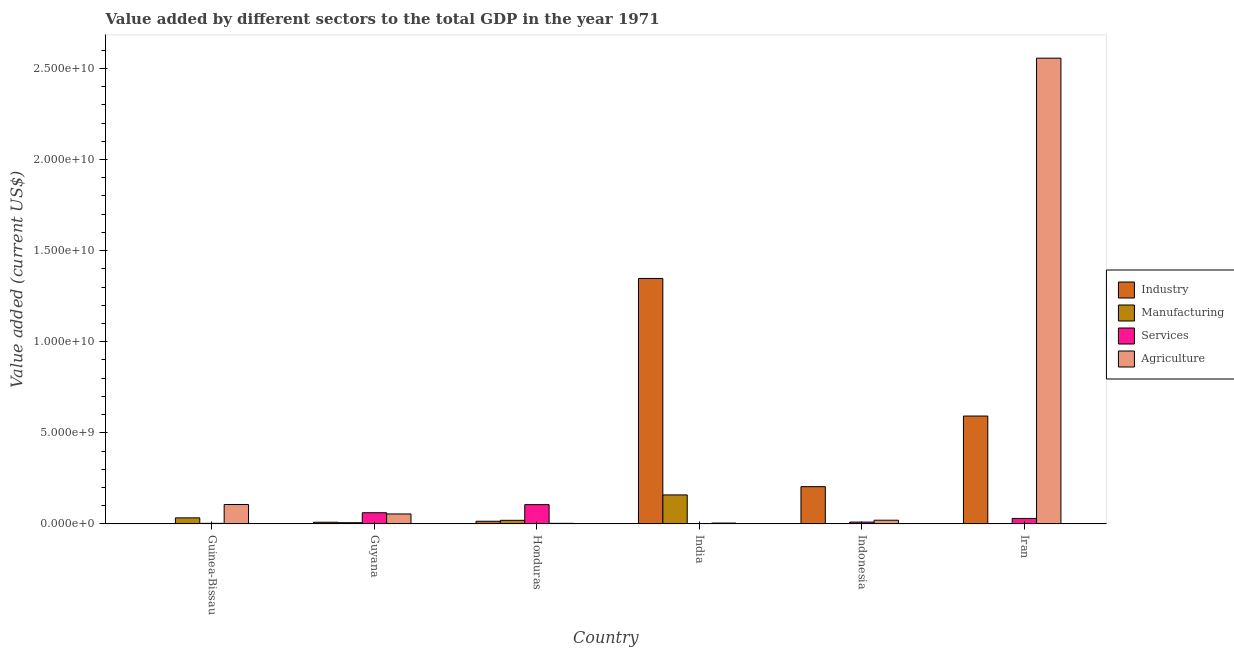How many groups of bars are there?
Provide a short and direct response. 6. What is the label of the 1st group of bars from the left?
Keep it short and to the point. Guinea-Bissau. In how many cases, is the number of bars for a given country not equal to the number of legend labels?
Offer a terse response. 0. What is the value added by industrial sector in Guinea-Bissau?
Provide a succinct answer. 1.73e+07. Across all countries, what is the maximum value added by industrial sector?
Your answer should be compact. 1.35e+1. Across all countries, what is the minimum value added by industrial sector?
Offer a terse response. 1.73e+07. In which country was the value added by agricultural sector maximum?
Your answer should be compact. Iran. What is the total value added by manufacturing sector in the graph?
Give a very brief answer. 2.22e+09. What is the difference between the value added by manufacturing sector in India and that in Indonesia?
Keep it short and to the point. 1.59e+09. What is the difference between the value added by services sector in Guyana and the value added by agricultural sector in India?
Offer a very short reply. 5.66e+08. What is the average value added by agricultural sector per country?
Make the answer very short. 4.58e+09. What is the difference between the value added by industrial sector and value added by manufacturing sector in Honduras?
Your answer should be very brief. -5.12e+07. In how many countries, is the value added by manufacturing sector greater than 6000000000 US$?
Ensure brevity in your answer.  0. What is the ratio of the value added by industrial sector in India to that in Iran?
Your response must be concise. 2.27. Is the value added by services sector in Guinea-Bissau less than that in Honduras?
Keep it short and to the point. Yes. What is the difference between the highest and the second highest value added by services sector?
Make the answer very short. 4.45e+08. What is the difference between the highest and the lowest value added by agricultural sector?
Offer a very short reply. 2.55e+1. In how many countries, is the value added by manufacturing sector greater than the average value added by manufacturing sector taken over all countries?
Ensure brevity in your answer.  1. Is the sum of the value added by agricultural sector in Guyana and Indonesia greater than the maximum value added by industrial sector across all countries?
Ensure brevity in your answer.  No. What does the 2nd bar from the left in India represents?
Make the answer very short. Manufacturing. What does the 2nd bar from the right in Indonesia represents?
Your response must be concise. Services. How many bars are there?
Keep it short and to the point. 24. What is the difference between two consecutive major ticks on the Y-axis?
Provide a short and direct response. 5.00e+09. Are the values on the major ticks of Y-axis written in scientific E-notation?
Keep it short and to the point. Yes. Does the graph contain grids?
Ensure brevity in your answer.  No. Where does the legend appear in the graph?
Offer a very short reply. Center right. What is the title of the graph?
Provide a short and direct response. Value added by different sectors to the total GDP in the year 1971. Does "Social Insurance" appear as one of the legend labels in the graph?
Give a very brief answer. No. What is the label or title of the Y-axis?
Ensure brevity in your answer.  Value added (current US$). What is the Value added (current US$) in Industry in Guinea-Bissau?
Provide a succinct answer. 1.73e+07. What is the Value added (current US$) in Manufacturing in Guinea-Bissau?
Give a very brief answer. 3.35e+08. What is the Value added (current US$) of Services in Guinea-Bissau?
Your answer should be compact. 3.42e+07. What is the Value added (current US$) in Agriculture in Guinea-Bissau?
Your answer should be compact. 1.07e+09. What is the Value added (current US$) of Industry in Guyana?
Your answer should be compact. 9.53e+07. What is the Value added (current US$) of Manufacturing in Guyana?
Keep it short and to the point. 7.08e+07. What is the Value added (current US$) of Services in Guyana?
Provide a succinct answer. 6.17e+08. What is the Value added (current US$) of Agriculture in Guyana?
Offer a terse response. 5.50e+08. What is the Value added (current US$) of Industry in Honduras?
Offer a very short reply. 1.50e+08. What is the Value added (current US$) of Manufacturing in Honduras?
Ensure brevity in your answer.  2.01e+08. What is the Value added (current US$) of Services in Honduras?
Offer a terse response. 1.06e+09. What is the Value added (current US$) of Agriculture in Honduras?
Your answer should be very brief. 3.52e+07. What is the Value added (current US$) in Industry in India?
Your answer should be very brief. 1.35e+1. What is the Value added (current US$) of Manufacturing in India?
Your response must be concise. 1.59e+09. What is the Value added (current US$) of Services in India?
Make the answer very short. 2.60e+07. What is the Value added (current US$) in Agriculture in India?
Your answer should be compact. 5.08e+07. What is the Value added (current US$) of Industry in Indonesia?
Your answer should be compact. 2.05e+09. What is the Value added (current US$) in Manufacturing in Indonesia?
Your response must be concise. 3.36e+06. What is the Value added (current US$) of Services in Indonesia?
Ensure brevity in your answer.  1.03e+08. What is the Value added (current US$) in Agriculture in Indonesia?
Offer a terse response. 2.06e+08. What is the Value added (current US$) of Industry in Iran?
Your answer should be compact. 5.92e+09. What is the Value added (current US$) of Manufacturing in Iran?
Provide a succinct answer. 1.46e+07. What is the Value added (current US$) of Services in Iran?
Ensure brevity in your answer.  3.04e+08. What is the Value added (current US$) in Agriculture in Iran?
Your answer should be very brief. 2.56e+1. Across all countries, what is the maximum Value added (current US$) of Industry?
Make the answer very short. 1.35e+1. Across all countries, what is the maximum Value added (current US$) in Manufacturing?
Your answer should be compact. 1.59e+09. Across all countries, what is the maximum Value added (current US$) of Services?
Provide a short and direct response. 1.06e+09. Across all countries, what is the maximum Value added (current US$) of Agriculture?
Your response must be concise. 2.56e+1. Across all countries, what is the minimum Value added (current US$) of Industry?
Offer a very short reply. 1.73e+07. Across all countries, what is the minimum Value added (current US$) of Manufacturing?
Provide a succinct answer. 3.36e+06. Across all countries, what is the minimum Value added (current US$) in Services?
Ensure brevity in your answer.  2.60e+07. Across all countries, what is the minimum Value added (current US$) in Agriculture?
Offer a terse response. 3.52e+07. What is the total Value added (current US$) in Industry in the graph?
Keep it short and to the point. 2.17e+1. What is the total Value added (current US$) of Manufacturing in the graph?
Offer a very short reply. 2.22e+09. What is the total Value added (current US$) of Services in the graph?
Your response must be concise. 2.15e+09. What is the total Value added (current US$) in Agriculture in the graph?
Provide a short and direct response. 2.75e+1. What is the difference between the Value added (current US$) of Industry in Guinea-Bissau and that in Guyana?
Your answer should be very brief. -7.80e+07. What is the difference between the Value added (current US$) of Manufacturing in Guinea-Bissau and that in Guyana?
Your answer should be very brief. 2.64e+08. What is the difference between the Value added (current US$) in Services in Guinea-Bissau and that in Guyana?
Offer a terse response. -5.83e+08. What is the difference between the Value added (current US$) of Agriculture in Guinea-Bissau and that in Guyana?
Offer a very short reply. 5.18e+08. What is the difference between the Value added (current US$) of Industry in Guinea-Bissau and that in Honduras?
Provide a succinct answer. -1.32e+08. What is the difference between the Value added (current US$) of Manufacturing in Guinea-Bissau and that in Honduras?
Provide a succinct answer. 1.35e+08. What is the difference between the Value added (current US$) of Services in Guinea-Bissau and that in Honduras?
Offer a terse response. -1.03e+09. What is the difference between the Value added (current US$) in Agriculture in Guinea-Bissau and that in Honduras?
Make the answer very short. 1.03e+09. What is the difference between the Value added (current US$) in Industry in Guinea-Bissau and that in India?
Your response must be concise. -1.35e+1. What is the difference between the Value added (current US$) in Manufacturing in Guinea-Bissau and that in India?
Give a very brief answer. -1.26e+09. What is the difference between the Value added (current US$) of Services in Guinea-Bissau and that in India?
Offer a very short reply. 8.27e+06. What is the difference between the Value added (current US$) in Agriculture in Guinea-Bissau and that in India?
Provide a short and direct response. 1.02e+09. What is the difference between the Value added (current US$) in Industry in Guinea-Bissau and that in Indonesia?
Offer a very short reply. -2.03e+09. What is the difference between the Value added (current US$) in Manufacturing in Guinea-Bissau and that in Indonesia?
Provide a short and direct response. 3.32e+08. What is the difference between the Value added (current US$) in Services in Guinea-Bissau and that in Indonesia?
Provide a succinct answer. -6.88e+07. What is the difference between the Value added (current US$) in Agriculture in Guinea-Bissau and that in Indonesia?
Ensure brevity in your answer.  8.61e+08. What is the difference between the Value added (current US$) of Industry in Guinea-Bissau and that in Iran?
Give a very brief answer. -5.91e+09. What is the difference between the Value added (current US$) in Manufacturing in Guinea-Bissau and that in Iran?
Give a very brief answer. 3.21e+08. What is the difference between the Value added (current US$) of Services in Guinea-Bissau and that in Iran?
Offer a terse response. -2.69e+08. What is the difference between the Value added (current US$) of Agriculture in Guinea-Bissau and that in Iran?
Keep it short and to the point. -2.45e+1. What is the difference between the Value added (current US$) of Industry in Guyana and that in Honduras?
Give a very brief answer. -5.42e+07. What is the difference between the Value added (current US$) in Manufacturing in Guyana and that in Honduras?
Provide a succinct answer. -1.30e+08. What is the difference between the Value added (current US$) in Services in Guyana and that in Honduras?
Your answer should be very brief. -4.45e+08. What is the difference between the Value added (current US$) in Agriculture in Guyana and that in Honduras?
Keep it short and to the point. 5.15e+08. What is the difference between the Value added (current US$) in Industry in Guyana and that in India?
Your response must be concise. -1.34e+1. What is the difference between the Value added (current US$) in Manufacturing in Guyana and that in India?
Ensure brevity in your answer.  -1.52e+09. What is the difference between the Value added (current US$) of Services in Guyana and that in India?
Your answer should be very brief. 5.91e+08. What is the difference between the Value added (current US$) of Agriculture in Guyana and that in India?
Your response must be concise. 4.99e+08. What is the difference between the Value added (current US$) of Industry in Guyana and that in Indonesia?
Your answer should be very brief. -1.95e+09. What is the difference between the Value added (current US$) in Manufacturing in Guyana and that in Indonesia?
Provide a succinct answer. 6.75e+07. What is the difference between the Value added (current US$) of Services in Guyana and that in Indonesia?
Your answer should be very brief. 5.14e+08. What is the difference between the Value added (current US$) in Agriculture in Guyana and that in Indonesia?
Offer a terse response. 3.43e+08. What is the difference between the Value added (current US$) of Industry in Guyana and that in Iran?
Make the answer very short. -5.83e+09. What is the difference between the Value added (current US$) in Manufacturing in Guyana and that in Iran?
Ensure brevity in your answer.  5.62e+07. What is the difference between the Value added (current US$) in Services in Guyana and that in Iran?
Provide a succinct answer. 3.13e+08. What is the difference between the Value added (current US$) of Agriculture in Guyana and that in Iran?
Make the answer very short. -2.50e+1. What is the difference between the Value added (current US$) in Industry in Honduras and that in India?
Provide a short and direct response. -1.33e+1. What is the difference between the Value added (current US$) of Manufacturing in Honduras and that in India?
Give a very brief answer. -1.39e+09. What is the difference between the Value added (current US$) of Services in Honduras and that in India?
Offer a very short reply. 1.04e+09. What is the difference between the Value added (current US$) of Agriculture in Honduras and that in India?
Keep it short and to the point. -1.56e+07. What is the difference between the Value added (current US$) in Industry in Honduras and that in Indonesia?
Your answer should be compact. -1.90e+09. What is the difference between the Value added (current US$) in Manufacturing in Honduras and that in Indonesia?
Your answer should be very brief. 1.97e+08. What is the difference between the Value added (current US$) of Services in Honduras and that in Indonesia?
Your response must be concise. 9.59e+08. What is the difference between the Value added (current US$) of Agriculture in Honduras and that in Indonesia?
Ensure brevity in your answer.  -1.71e+08. What is the difference between the Value added (current US$) of Industry in Honduras and that in Iran?
Give a very brief answer. -5.77e+09. What is the difference between the Value added (current US$) of Manufacturing in Honduras and that in Iran?
Your answer should be compact. 1.86e+08. What is the difference between the Value added (current US$) in Services in Honduras and that in Iran?
Keep it short and to the point. 7.58e+08. What is the difference between the Value added (current US$) in Agriculture in Honduras and that in Iran?
Give a very brief answer. -2.55e+1. What is the difference between the Value added (current US$) in Industry in India and that in Indonesia?
Offer a terse response. 1.14e+1. What is the difference between the Value added (current US$) in Manufacturing in India and that in Indonesia?
Your response must be concise. 1.59e+09. What is the difference between the Value added (current US$) of Services in India and that in Indonesia?
Provide a short and direct response. -7.71e+07. What is the difference between the Value added (current US$) of Agriculture in India and that in Indonesia?
Your response must be concise. -1.56e+08. What is the difference between the Value added (current US$) of Industry in India and that in Iran?
Keep it short and to the point. 7.55e+09. What is the difference between the Value added (current US$) of Manufacturing in India and that in Iran?
Provide a short and direct response. 1.58e+09. What is the difference between the Value added (current US$) in Services in India and that in Iran?
Ensure brevity in your answer.  -2.78e+08. What is the difference between the Value added (current US$) of Agriculture in India and that in Iran?
Ensure brevity in your answer.  -2.55e+1. What is the difference between the Value added (current US$) in Industry in Indonesia and that in Iran?
Provide a short and direct response. -3.88e+09. What is the difference between the Value added (current US$) in Manufacturing in Indonesia and that in Iran?
Offer a terse response. -1.12e+07. What is the difference between the Value added (current US$) in Services in Indonesia and that in Iran?
Your answer should be compact. -2.00e+08. What is the difference between the Value added (current US$) in Agriculture in Indonesia and that in Iran?
Provide a short and direct response. -2.54e+1. What is the difference between the Value added (current US$) of Industry in Guinea-Bissau and the Value added (current US$) of Manufacturing in Guyana?
Offer a terse response. -5.35e+07. What is the difference between the Value added (current US$) in Industry in Guinea-Bissau and the Value added (current US$) in Services in Guyana?
Offer a terse response. -6.00e+08. What is the difference between the Value added (current US$) of Industry in Guinea-Bissau and the Value added (current US$) of Agriculture in Guyana?
Ensure brevity in your answer.  -5.32e+08. What is the difference between the Value added (current US$) of Manufacturing in Guinea-Bissau and the Value added (current US$) of Services in Guyana?
Make the answer very short. -2.82e+08. What is the difference between the Value added (current US$) in Manufacturing in Guinea-Bissau and the Value added (current US$) in Agriculture in Guyana?
Offer a very short reply. -2.15e+08. What is the difference between the Value added (current US$) in Services in Guinea-Bissau and the Value added (current US$) in Agriculture in Guyana?
Offer a terse response. -5.16e+08. What is the difference between the Value added (current US$) of Industry in Guinea-Bissau and the Value added (current US$) of Manufacturing in Honduras?
Offer a very short reply. -1.83e+08. What is the difference between the Value added (current US$) of Industry in Guinea-Bissau and the Value added (current US$) of Services in Honduras?
Offer a very short reply. -1.04e+09. What is the difference between the Value added (current US$) in Industry in Guinea-Bissau and the Value added (current US$) in Agriculture in Honduras?
Your answer should be very brief. -1.79e+07. What is the difference between the Value added (current US$) of Manufacturing in Guinea-Bissau and the Value added (current US$) of Services in Honduras?
Your response must be concise. -7.26e+08. What is the difference between the Value added (current US$) in Manufacturing in Guinea-Bissau and the Value added (current US$) in Agriculture in Honduras?
Offer a terse response. 3.00e+08. What is the difference between the Value added (current US$) of Services in Guinea-Bissau and the Value added (current US$) of Agriculture in Honduras?
Keep it short and to the point. -9.85e+05. What is the difference between the Value added (current US$) of Industry in Guinea-Bissau and the Value added (current US$) of Manufacturing in India?
Provide a succinct answer. -1.58e+09. What is the difference between the Value added (current US$) of Industry in Guinea-Bissau and the Value added (current US$) of Services in India?
Your response must be concise. -8.63e+06. What is the difference between the Value added (current US$) in Industry in Guinea-Bissau and the Value added (current US$) in Agriculture in India?
Your answer should be very brief. -3.35e+07. What is the difference between the Value added (current US$) in Manufacturing in Guinea-Bissau and the Value added (current US$) in Services in India?
Your answer should be compact. 3.09e+08. What is the difference between the Value added (current US$) of Manufacturing in Guinea-Bissau and the Value added (current US$) of Agriculture in India?
Make the answer very short. 2.84e+08. What is the difference between the Value added (current US$) in Services in Guinea-Bissau and the Value added (current US$) in Agriculture in India?
Offer a very short reply. -1.66e+07. What is the difference between the Value added (current US$) in Industry in Guinea-Bissau and the Value added (current US$) in Manufacturing in Indonesia?
Give a very brief answer. 1.40e+07. What is the difference between the Value added (current US$) of Industry in Guinea-Bissau and the Value added (current US$) of Services in Indonesia?
Offer a very short reply. -8.57e+07. What is the difference between the Value added (current US$) of Industry in Guinea-Bissau and the Value added (current US$) of Agriculture in Indonesia?
Give a very brief answer. -1.89e+08. What is the difference between the Value added (current US$) in Manufacturing in Guinea-Bissau and the Value added (current US$) in Services in Indonesia?
Offer a very short reply. 2.32e+08. What is the difference between the Value added (current US$) of Manufacturing in Guinea-Bissau and the Value added (current US$) of Agriculture in Indonesia?
Your answer should be compact. 1.29e+08. What is the difference between the Value added (current US$) of Services in Guinea-Bissau and the Value added (current US$) of Agriculture in Indonesia?
Ensure brevity in your answer.  -1.72e+08. What is the difference between the Value added (current US$) of Industry in Guinea-Bissau and the Value added (current US$) of Manufacturing in Iran?
Your answer should be compact. 2.74e+06. What is the difference between the Value added (current US$) in Industry in Guinea-Bissau and the Value added (current US$) in Services in Iran?
Your response must be concise. -2.86e+08. What is the difference between the Value added (current US$) of Industry in Guinea-Bissau and the Value added (current US$) of Agriculture in Iran?
Give a very brief answer. -2.55e+1. What is the difference between the Value added (current US$) in Manufacturing in Guinea-Bissau and the Value added (current US$) in Services in Iran?
Your response must be concise. 3.17e+07. What is the difference between the Value added (current US$) in Manufacturing in Guinea-Bissau and the Value added (current US$) in Agriculture in Iran?
Provide a succinct answer. -2.52e+1. What is the difference between the Value added (current US$) of Services in Guinea-Bissau and the Value added (current US$) of Agriculture in Iran?
Provide a succinct answer. -2.55e+1. What is the difference between the Value added (current US$) of Industry in Guyana and the Value added (current US$) of Manufacturing in Honduras?
Make the answer very short. -1.05e+08. What is the difference between the Value added (current US$) of Industry in Guyana and the Value added (current US$) of Services in Honduras?
Provide a succinct answer. -9.66e+08. What is the difference between the Value added (current US$) in Industry in Guyana and the Value added (current US$) in Agriculture in Honduras?
Offer a very short reply. 6.01e+07. What is the difference between the Value added (current US$) of Manufacturing in Guyana and the Value added (current US$) of Services in Honduras?
Your answer should be very brief. -9.91e+08. What is the difference between the Value added (current US$) of Manufacturing in Guyana and the Value added (current US$) of Agriculture in Honduras?
Offer a terse response. 3.56e+07. What is the difference between the Value added (current US$) in Services in Guyana and the Value added (current US$) in Agriculture in Honduras?
Your response must be concise. 5.82e+08. What is the difference between the Value added (current US$) in Industry in Guyana and the Value added (current US$) in Manufacturing in India?
Offer a terse response. -1.50e+09. What is the difference between the Value added (current US$) of Industry in Guyana and the Value added (current US$) of Services in India?
Your answer should be very brief. 6.93e+07. What is the difference between the Value added (current US$) of Industry in Guyana and the Value added (current US$) of Agriculture in India?
Your answer should be very brief. 4.44e+07. What is the difference between the Value added (current US$) of Manufacturing in Guyana and the Value added (current US$) of Services in India?
Your response must be concise. 4.49e+07. What is the difference between the Value added (current US$) of Manufacturing in Guyana and the Value added (current US$) of Agriculture in India?
Keep it short and to the point. 2.00e+07. What is the difference between the Value added (current US$) of Services in Guyana and the Value added (current US$) of Agriculture in India?
Make the answer very short. 5.66e+08. What is the difference between the Value added (current US$) of Industry in Guyana and the Value added (current US$) of Manufacturing in Indonesia?
Provide a short and direct response. 9.19e+07. What is the difference between the Value added (current US$) in Industry in Guyana and the Value added (current US$) in Services in Indonesia?
Your answer should be very brief. -7.75e+06. What is the difference between the Value added (current US$) of Industry in Guyana and the Value added (current US$) of Agriculture in Indonesia?
Make the answer very short. -1.11e+08. What is the difference between the Value added (current US$) in Manufacturing in Guyana and the Value added (current US$) in Services in Indonesia?
Give a very brief answer. -3.22e+07. What is the difference between the Value added (current US$) in Manufacturing in Guyana and the Value added (current US$) in Agriculture in Indonesia?
Make the answer very short. -1.36e+08. What is the difference between the Value added (current US$) in Services in Guyana and the Value added (current US$) in Agriculture in Indonesia?
Offer a terse response. 4.10e+08. What is the difference between the Value added (current US$) in Industry in Guyana and the Value added (current US$) in Manufacturing in Iran?
Give a very brief answer. 8.07e+07. What is the difference between the Value added (current US$) in Industry in Guyana and the Value added (current US$) in Services in Iran?
Give a very brief answer. -2.08e+08. What is the difference between the Value added (current US$) of Industry in Guyana and the Value added (current US$) of Agriculture in Iran?
Your answer should be very brief. -2.55e+1. What is the difference between the Value added (current US$) in Manufacturing in Guyana and the Value added (current US$) in Services in Iran?
Offer a terse response. -2.33e+08. What is the difference between the Value added (current US$) in Manufacturing in Guyana and the Value added (current US$) in Agriculture in Iran?
Your response must be concise. -2.55e+1. What is the difference between the Value added (current US$) in Services in Guyana and the Value added (current US$) in Agriculture in Iran?
Your answer should be very brief. -2.49e+1. What is the difference between the Value added (current US$) of Industry in Honduras and the Value added (current US$) of Manufacturing in India?
Provide a succinct answer. -1.45e+09. What is the difference between the Value added (current US$) of Industry in Honduras and the Value added (current US$) of Services in India?
Keep it short and to the point. 1.24e+08. What is the difference between the Value added (current US$) in Industry in Honduras and the Value added (current US$) in Agriculture in India?
Provide a short and direct response. 9.86e+07. What is the difference between the Value added (current US$) in Manufacturing in Honduras and the Value added (current US$) in Services in India?
Your response must be concise. 1.75e+08. What is the difference between the Value added (current US$) in Manufacturing in Honduras and the Value added (current US$) in Agriculture in India?
Provide a succinct answer. 1.50e+08. What is the difference between the Value added (current US$) in Services in Honduras and the Value added (current US$) in Agriculture in India?
Offer a terse response. 1.01e+09. What is the difference between the Value added (current US$) in Industry in Honduras and the Value added (current US$) in Manufacturing in Indonesia?
Keep it short and to the point. 1.46e+08. What is the difference between the Value added (current US$) of Industry in Honduras and the Value added (current US$) of Services in Indonesia?
Give a very brief answer. 4.64e+07. What is the difference between the Value added (current US$) of Industry in Honduras and the Value added (current US$) of Agriculture in Indonesia?
Keep it short and to the point. -5.70e+07. What is the difference between the Value added (current US$) in Manufacturing in Honduras and the Value added (current US$) in Services in Indonesia?
Your response must be concise. 9.77e+07. What is the difference between the Value added (current US$) in Manufacturing in Honduras and the Value added (current US$) in Agriculture in Indonesia?
Provide a short and direct response. -5.80e+06. What is the difference between the Value added (current US$) in Services in Honduras and the Value added (current US$) in Agriculture in Indonesia?
Your answer should be very brief. 8.55e+08. What is the difference between the Value added (current US$) of Industry in Honduras and the Value added (current US$) of Manufacturing in Iran?
Ensure brevity in your answer.  1.35e+08. What is the difference between the Value added (current US$) of Industry in Honduras and the Value added (current US$) of Services in Iran?
Offer a very short reply. -1.54e+08. What is the difference between the Value added (current US$) of Industry in Honduras and the Value added (current US$) of Agriculture in Iran?
Provide a succinct answer. -2.54e+1. What is the difference between the Value added (current US$) in Manufacturing in Honduras and the Value added (current US$) in Services in Iran?
Provide a short and direct response. -1.03e+08. What is the difference between the Value added (current US$) in Manufacturing in Honduras and the Value added (current US$) in Agriculture in Iran?
Provide a short and direct response. -2.54e+1. What is the difference between the Value added (current US$) of Services in Honduras and the Value added (current US$) of Agriculture in Iran?
Provide a short and direct response. -2.45e+1. What is the difference between the Value added (current US$) in Industry in India and the Value added (current US$) in Manufacturing in Indonesia?
Your response must be concise. 1.35e+1. What is the difference between the Value added (current US$) in Industry in India and the Value added (current US$) in Services in Indonesia?
Offer a very short reply. 1.34e+1. What is the difference between the Value added (current US$) of Industry in India and the Value added (current US$) of Agriculture in Indonesia?
Provide a short and direct response. 1.33e+1. What is the difference between the Value added (current US$) in Manufacturing in India and the Value added (current US$) in Services in Indonesia?
Your answer should be very brief. 1.49e+09. What is the difference between the Value added (current US$) of Manufacturing in India and the Value added (current US$) of Agriculture in Indonesia?
Provide a short and direct response. 1.39e+09. What is the difference between the Value added (current US$) of Services in India and the Value added (current US$) of Agriculture in Indonesia?
Keep it short and to the point. -1.81e+08. What is the difference between the Value added (current US$) of Industry in India and the Value added (current US$) of Manufacturing in Iran?
Provide a short and direct response. 1.35e+1. What is the difference between the Value added (current US$) of Industry in India and the Value added (current US$) of Services in Iran?
Ensure brevity in your answer.  1.32e+1. What is the difference between the Value added (current US$) of Industry in India and the Value added (current US$) of Agriculture in Iran?
Ensure brevity in your answer.  -1.21e+1. What is the difference between the Value added (current US$) in Manufacturing in India and the Value added (current US$) in Services in Iran?
Provide a short and direct response. 1.29e+09. What is the difference between the Value added (current US$) of Manufacturing in India and the Value added (current US$) of Agriculture in Iran?
Provide a short and direct response. -2.40e+1. What is the difference between the Value added (current US$) in Services in India and the Value added (current US$) in Agriculture in Iran?
Offer a terse response. -2.55e+1. What is the difference between the Value added (current US$) in Industry in Indonesia and the Value added (current US$) in Manufacturing in Iran?
Your answer should be compact. 2.03e+09. What is the difference between the Value added (current US$) in Industry in Indonesia and the Value added (current US$) in Services in Iran?
Ensure brevity in your answer.  1.74e+09. What is the difference between the Value added (current US$) of Industry in Indonesia and the Value added (current US$) of Agriculture in Iran?
Your answer should be very brief. -2.35e+1. What is the difference between the Value added (current US$) in Manufacturing in Indonesia and the Value added (current US$) in Services in Iran?
Provide a short and direct response. -3.00e+08. What is the difference between the Value added (current US$) of Manufacturing in Indonesia and the Value added (current US$) of Agriculture in Iran?
Keep it short and to the point. -2.56e+1. What is the difference between the Value added (current US$) of Services in Indonesia and the Value added (current US$) of Agriculture in Iran?
Provide a succinct answer. -2.55e+1. What is the average Value added (current US$) of Industry per country?
Provide a succinct answer. 3.62e+09. What is the average Value added (current US$) in Manufacturing per country?
Your answer should be compact. 3.70e+08. What is the average Value added (current US$) in Services per country?
Keep it short and to the point. 3.58e+08. What is the average Value added (current US$) in Agriculture per country?
Your answer should be compact. 4.58e+09. What is the difference between the Value added (current US$) in Industry and Value added (current US$) in Manufacturing in Guinea-Bissau?
Provide a succinct answer. -3.18e+08. What is the difference between the Value added (current US$) in Industry and Value added (current US$) in Services in Guinea-Bissau?
Offer a terse response. -1.69e+07. What is the difference between the Value added (current US$) in Industry and Value added (current US$) in Agriculture in Guinea-Bissau?
Offer a very short reply. -1.05e+09. What is the difference between the Value added (current US$) of Manufacturing and Value added (current US$) of Services in Guinea-Bissau?
Your answer should be compact. 3.01e+08. What is the difference between the Value added (current US$) in Manufacturing and Value added (current US$) in Agriculture in Guinea-Bissau?
Keep it short and to the point. -7.32e+08. What is the difference between the Value added (current US$) in Services and Value added (current US$) in Agriculture in Guinea-Bissau?
Your response must be concise. -1.03e+09. What is the difference between the Value added (current US$) of Industry and Value added (current US$) of Manufacturing in Guyana?
Your answer should be compact. 2.45e+07. What is the difference between the Value added (current US$) of Industry and Value added (current US$) of Services in Guyana?
Your answer should be compact. -5.22e+08. What is the difference between the Value added (current US$) in Industry and Value added (current US$) in Agriculture in Guyana?
Your response must be concise. -4.54e+08. What is the difference between the Value added (current US$) in Manufacturing and Value added (current US$) in Services in Guyana?
Ensure brevity in your answer.  -5.46e+08. What is the difference between the Value added (current US$) in Manufacturing and Value added (current US$) in Agriculture in Guyana?
Your response must be concise. -4.79e+08. What is the difference between the Value added (current US$) of Services and Value added (current US$) of Agriculture in Guyana?
Your response must be concise. 6.71e+07. What is the difference between the Value added (current US$) in Industry and Value added (current US$) in Manufacturing in Honduras?
Offer a very short reply. -5.12e+07. What is the difference between the Value added (current US$) in Industry and Value added (current US$) in Services in Honduras?
Offer a terse response. -9.12e+08. What is the difference between the Value added (current US$) in Industry and Value added (current US$) in Agriculture in Honduras?
Keep it short and to the point. 1.14e+08. What is the difference between the Value added (current US$) in Manufacturing and Value added (current US$) in Services in Honduras?
Offer a very short reply. -8.61e+08. What is the difference between the Value added (current US$) of Manufacturing and Value added (current US$) of Agriculture in Honduras?
Provide a short and direct response. 1.65e+08. What is the difference between the Value added (current US$) in Services and Value added (current US$) in Agriculture in Honduras?
Make the answer very short. 1.03e+09. What is the difference between the Value added (current US$) in Industry and Value added (current US$) in Manufacturing in India?
Provide a succinct answer. 1.19e+1. What is the difference between the Value added (current US$) of Industry and Value added (current US$) of Services in India?
Provide a short and direct response. 1.34e+1. What is the difference between the Value added (current US$) in Industry and Value added (current US$) in Agriculture in India?
Offer a terse response. 1.34e+1. What is the difference between the Value added (current US$) in Manufacturing and Value added (current US$) in Services in India?
Give a very brief answer. 1.57e+09. What is the difference between the Value added (current US$) in Manufacturing and Value added (current US$) in Agriculture in India?
Give a very brief answer. 1.54e+09. What is the difference between the Value added (current US$) of Services and Value added (current US$) of Agriculture in India?
Your answer should be very brief. -2.49e+07. What is the difference between the Value added (current US$) of Industry and Value added (current US$) of Manufacturing in Indonesia?
Your response must be concise. 2.04e+09. What is the difference between the Value added (current US$) in Industry and Value added (current US$) in Services in Indonesia?
Offer a terse response. 1.94e+09. What is the difference between the Value added (current US$) of Industry and Value added (current US$) of Agriculture in Indonesia?
Your answer should be compact. 1.84e+09. What is the difference between the Value added (current US$) in Manufacturing and Value added (current US$) in Services in Indonesia?
Ensure brevity in your answer.  -9.97e+07. What is the difference between the Value added (current US$) in Manufacturing and Value added (current US$) in Agriculture in Indonesia?
Keep it short and to the point. -2.03e+08. What is the difference between the Value added (current US$) in Services and Value added (current US$) in Agriculture in Indonesia?
Offer a very short reply. -1.03e+08. What is the difference between the Value added (current US$) in Industry and Value added (current US$) in Manufacturing in Iran?
Offer a very short reply. 5.91e+09. What is the difference between the Value added (current US$) of Industry and Value added (current US$) of Services in Iran?
Your answer should be very brief. 5.62e+09. What is the difference between the Value added (current US$) in Industry and Value added (current US$) in Agriculture in Iran?
Provide a succinct answer. -1.96e+1. What is the difference between the Value added (current US$) in Manufacturing and Value added (current US$) in Services in Iran?
Keep it short and to the point. -2.89e+08. What is the difference between the Value added (current US$) of Manufacturing and Value added (current US$) of Agriculture in Iran?
Offer a terse response. -2.55e+1. What is the difference between the Value added (current US$) in Services and Value added (current US$) in Agriculture in Iran?
Offer a terse response. -2.53e+1. What is the ratio of the Value added (current US$) in Industry in Guinea-Bissau to that in Guyana?
Offer a terse response. 0.18. What is the ratio of the Value added (current US$) in Manufacturing in Guinea-Bissau to that in Guyana?
Offer a very short reply. 4.73. What is the ratio of the Value added (current US$) of Services in Guinea-Bissau to that in Guyana?
Your response must be concise. 0.06. What is the ratio of the Value added (current US$) of Agriculture in Guinea-Bissau to that in Guyana?
Provide a succinct answer. 1.94. What is the ratio of the Value added (current US$) in Industry in Guinea-Bissau to that in Honduras?
Ensure brevity in your answer.  0.12. What is the ratio of the Value added (current US$) of Manufacturing in Guinea-Bissau to that in Honduras?
Make the answer very short. 1.67. What is the ratio of the Value added (current US$) in Services in Guinea-Bissau to that in Honduras?
Your response must be concise. 0.03. What is the ratio of the Value added (current US$) of Agriculture in Guinea-Bissau to that in Honduras?
Offer a terse response. 30.3. What is the ratio of the Value added (current US$) of Industry in Guinea-Bissau to that in India?
Keep it short and to the point. 0. What is the ratio of the Value added (current US$) of Manufacturing in Guinea-Bissau to that in India?
Provide a short and direct response. 0.21. What is the ratio of the Value added (current US$) of Services in Guinea-Bissau to that in India?
Your response must be concise. 1.32. What is the ratio of the Value added (current US$) in Agriculture in Guinea-Bissau to that in India?
Give a very brief answer. 20.99. What is the ratio of the Value added (current US$) of Industry in Guinea-Bissau to that in Indonesia?
Offer a very short reply. 0.01. What is the ratio of the Value added (current US$) of Manufacturing in Guinea-Bissau to that in Indonesia?
Ensure brevity in your answer.  99.9. What is the ratio of the Value added (current US$) in Services in Guinea-Bissau to that in Indonesia?
Provide a succinct answer. 0.33. What is the ratio of the Value added (current US$) of Agriculture in Guinea-Bissau to that in Indonesia?
Your answer should be very brief. 5.17. What is the ratio of the Value added (current US$) in Industry in Guinea-Bissau to that in Iran?
Your answer should be compact. 0. What is the ratio of the Value added (current US$) in Manufacturing in Guinea-Bissau to that in Iran?
Your answer should be compact. 22.96. What is the ratio of the Value added (current US$) of Services in Guinea-Bissau to that in Iran?
Make the answer very short. 0.11. What is the ratio of the Value added (current US$) of Agriculture in Guinea-Bissau to that in Iran?
Give a very brief answer. 0.04. What is the ratio of the Value added (current US$) in Industry in Guyana to that in Honduras?
Make the answer very short. 0.64. What is the ratio of the Value added (current US$) in Manufacturing in Guyana to that in Honduras?
Give a very brief answer. 0.35. What is the ratio of the Value added (current US$) of Services in Guyana to that in Honduras?
Your answer should be very brief. 0.58. What is the ratio of the Value added (current US$) in Agriculture in Guyana to that in Honduras?
Provide a short and direct response. 15.61. What is the ratio of the Value added (current US$) in Industry in Guyana to that in India?
Provide a succinct answer. 0.01. What is the ratio of the Value added (current US$) of Manufacturing in Guyana to that in India?
Provide a succinct answer. 0.04. What is the ratio of the Value added (current US$) in Services in Guyana to that in India?
Offer a terse response. 23.75. What is the ratio of the Value added (current US$) in Agriculture in Guyana to that in India?
Give a very brief answer. 10.81. What is the ratio of the Value added (current US$) of Industry in Guyana to that in Indonesia?
Provide a short and direct response. 0.05. What is the ratio of the Value added (current US$) in Manufacturing in Guyana to that in Indonesia?
Make the answer very short. 21.11. What is the ratio of the Value added (current US$) of Services in Guyana to that in Indonesia?
Keep it short and to the point. 5.99. What is the ratio of the Value added (current US$) of Agriculture in Guyana to that in Indonesia?
Offer a terse response. 2.66. What is the ratio of the Value added (current US$) in Industry in Guyana to that in Iran?
Provide a succinct answer. 0.02. What is the ratio of the Value added (current US$) of Manufacturing in Guyana to that in Iran?
Your answer should be very brief. 4.85. What is the ratio of the Value added (current US$) in Services in Guyana to that in Iran?
Offer a terse response. 2.03. What is the ratio of the Value added (current US$) in Agriculture in Guyana to that in Iran?
Keep it short and to the point. 0.02. What is the ratio of the Value added (current US$) of Industry in Honduras to that in India?
Ensure brevity in your answer.  0.01. What is the ratio of the Value added (current US$) of Manufacturing in Honduras to that in India?
Provide a short and direct response. 0.13. What is the ratio of the Value added (current US$) in Services in Honduras to that in India?
Your response must be concise. 40.87. What is the ratio of the Value added (current US$) of Agriculture in Honduras to that in India?
Your answer should be compact. 0.69. What is the ratio of the Value added (current US$) of Industry in Honduras to that in Indonesia?
Provide a succinct answer. 0.07. What is the ratio of the Value added (current US$) of Manufacturing in Honduras to that in Indonesia?
Provide a succinct answer. 59.81. What is the ratio of the Value added (current US$) in Services in Honduras to that in Indonesia?
Provide a succinct answer. 10.3. What is the ratio of the Value added (current US$) of Agriculture in Honduras to that in Indonesia?
Provide a succinct answer. 0.17. What is the ratio of the Value added (current US$) of Industry in Honduras to that in Iran?
Provide a short and direct response. 0.03. What is the ratio of the Value added (current US$) of Manufacturing in Honduras to that in Iran?
Provide a succinct answer. 13.75. What is the ratio of the Value added (current US$) in Services in Honduras to that in Iran?
Offer a very short reply. 3.5. What is the ratio of the Value added (current US$) in Agriculture in Honduras to that in Iran?
Ensure brevity in your answer.  0. What is the ratio of the Value added (current US$) of Industry in India to that in Indonesia?
Keep it short and to the point. 6.58. What is the ratio of the Value added (current US$) of Manufacturing in India to that in Indonesia?
Provide a short and direct response. 475.23. What is the ratio of the Value added (current US$) of Services in India to that in Indonesia?
Provide a succinct answer. 0.25. What is the ratio of the Value added (current US$) of Agriculture in India to that in Indonesia?
Give a very brief answer. 0.25. What is the ratio of the Value added (current US$) of Industry in India to that in Iran?
Keep it short and to the point. 2.27. What is the ratio of the Value added (current US$) of Manufacturing in India to that in Iran?
Ensure brevity in your answer.  109.22. What is the ratio of the Value added (current US$) in Services in India to that in Iran?
Ensure brevity in your answer.  0.09. What is the ratio of the Value added (current US$) of Agriculture in India to that in Iran?
Ensure brevity in your answer.  0. What is the ratio of the Value added (current US$) of Industry in Indonesia to that in Iran?
Your response must be concise. 0.35. What is the ratio of the Value added (current US$) in Manufacturing in Indonesia to that in Iran?
Provide a succinct answer. 0.23. What is the ratio of the Value added (current US$) of Services in Indonesia to that in Iran?
Offer a terse response. 0.34. What is the ratio of the Value added (current US$) in Agriculture in Indonesia to that in Iran?
Your response must be concise. 0.01. What is the difference between the highest and the second highest Value added (current US$) of Industry?
Ensure brevity in your answer.  7.55e+09. What is the difference between the highest and the second highest Value added (current US$) in Manufacturing?
Your answer should be compact. 1.26e+09. What is the difference between the highest and the second highest Value added (current US$) in Services?
Make the answer very short. 4.45e+08. What is the difference between the highest and the second highest Value added (current US$) in Agriculture?
Keep it short and to the point. 2.45e+1. What is the difference between the highest and the lowest Value added (current US$) in Industry?
Offer a very short reply. 1.35e+1. What is the difference between the highest and the lowest Value added (current US$) in Manufacturing?
Your answer should be compact. 1.59e+09. What is the difference between the highest and the lowest Value added (current US$) of Services?
Provide a short and direct response. 1.04e+09. What is the difference between the highest and the lowest Value added (current US$) in Agriculture?
Your answer should be compact. 2.55e+1. 